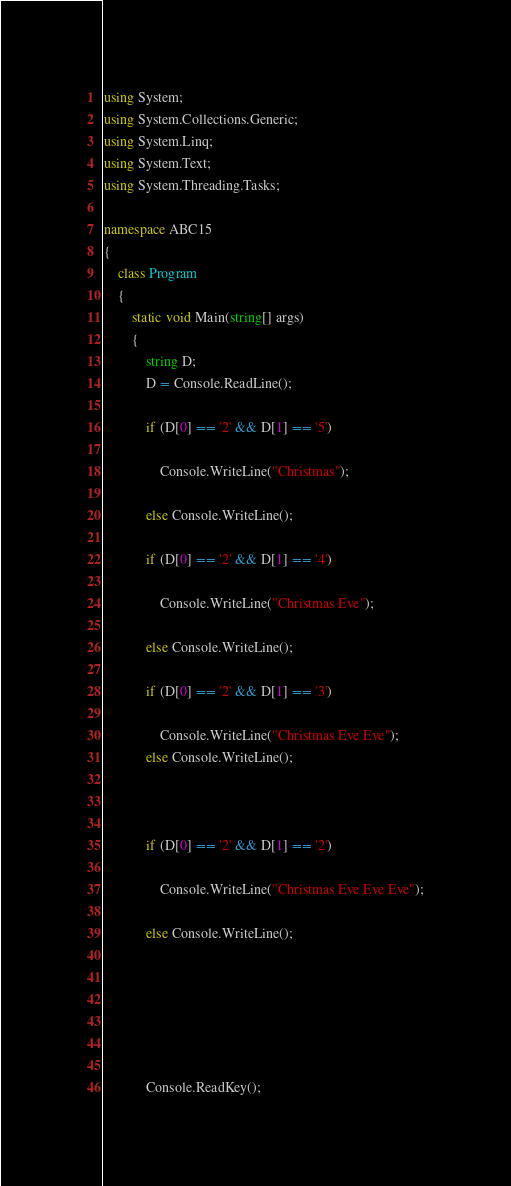Convert code to text. <code><loc_0><loc_0><loc_500><loc_500><_C#_>using System;
using System.Collections.Generic;
using System.Linq;
using System.Text;
using System.Threading.Tasks;

namespace ABC15
{
	class Program
	{
		static void Main(string[] args)
		{
			string D;
			D = Console.ReadLine();

			if (D[0] == '2' && D[1] == '5')

				Console.WriteLine("Christmas");

			else Console.WriteLine();

			if (D[0] == '2' && D[1] == '4')

				Console.WriteLine("Christmas Eve");

			else Console.WriteLine();

			if (D[0] == '2' && D[1] == '3')

				Console.WriteLine("Christmas Eve Eve");
			else Console.WriteLine();



			if (D[0] == '2' && D[1] == '2')

				Console.WriteLine("Christmas Eve Eve Eve");

			else Console.WriteLine();





			 
			Console.ReadKey();</code> 